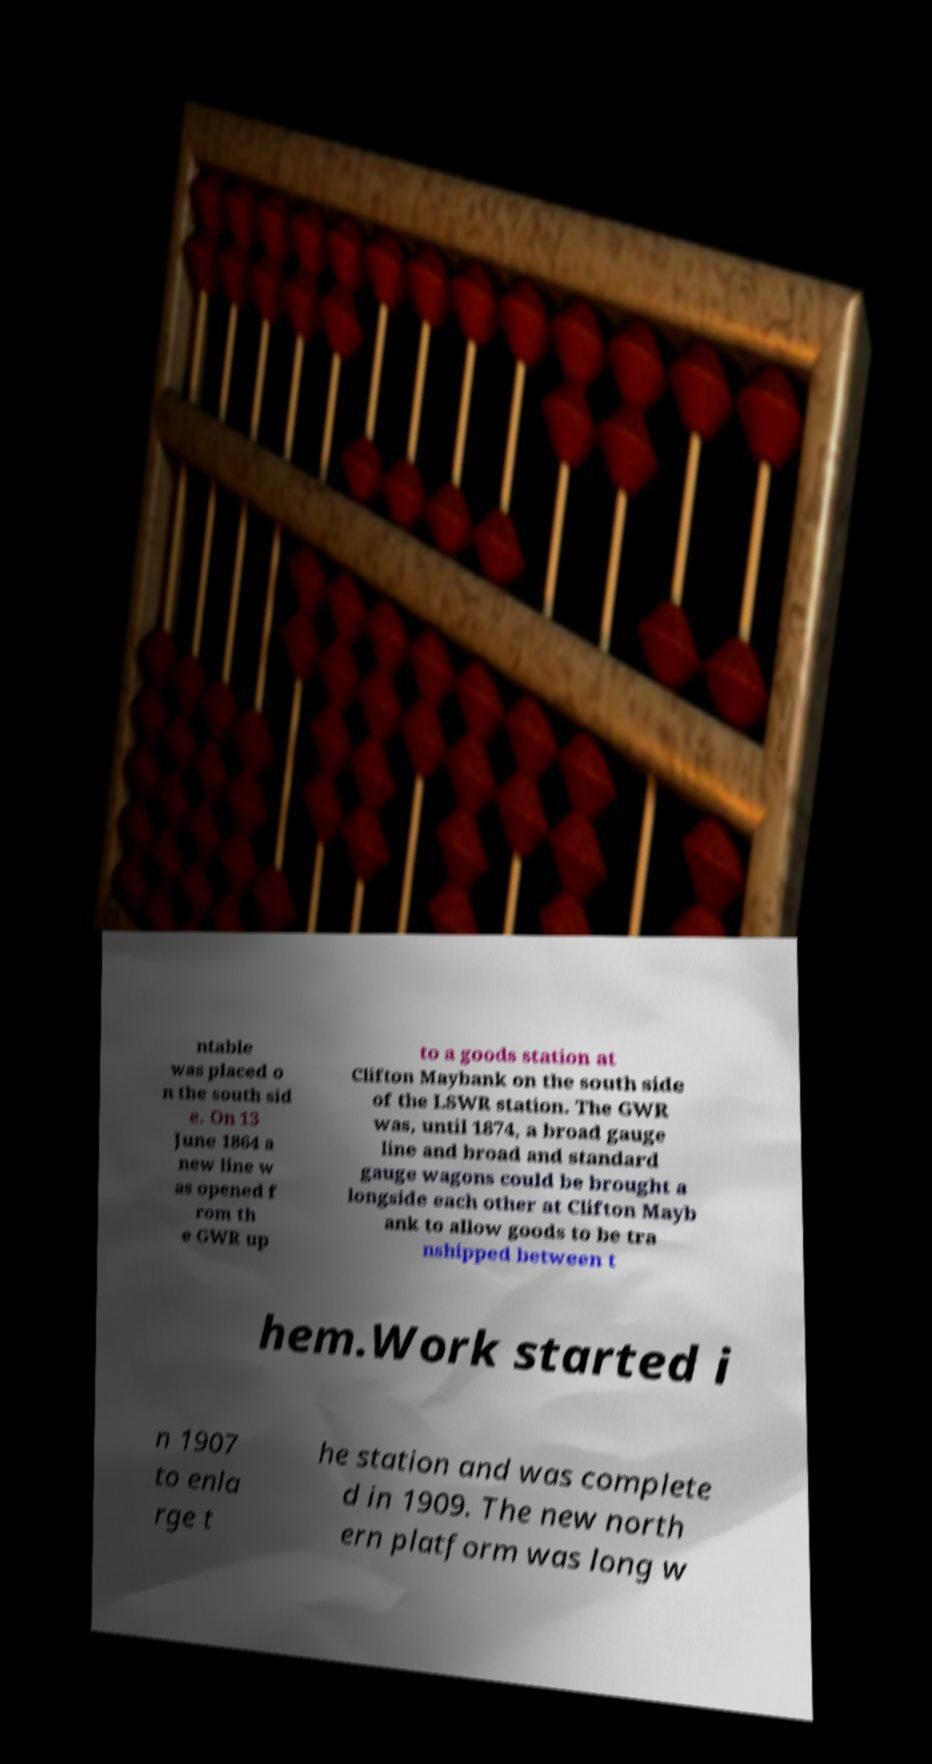Please identify and transcribe the text found in this image. ntable was placed o n the south sid e. On 13 June 1864 a new line w as opened f rom th e GWR up to a goods station at Clifton Maybank on the south side of the LSWR station. The GWR was, until 1874, a broad gauge line and broad and standard gauge wagons could be brought a longside each other at Clifton Mayb ank to allow goods to be tra nshipped between t hem.Work started i n 1907 to enla rge t he station and was complete d in 1909. The new north ern platform was long w 